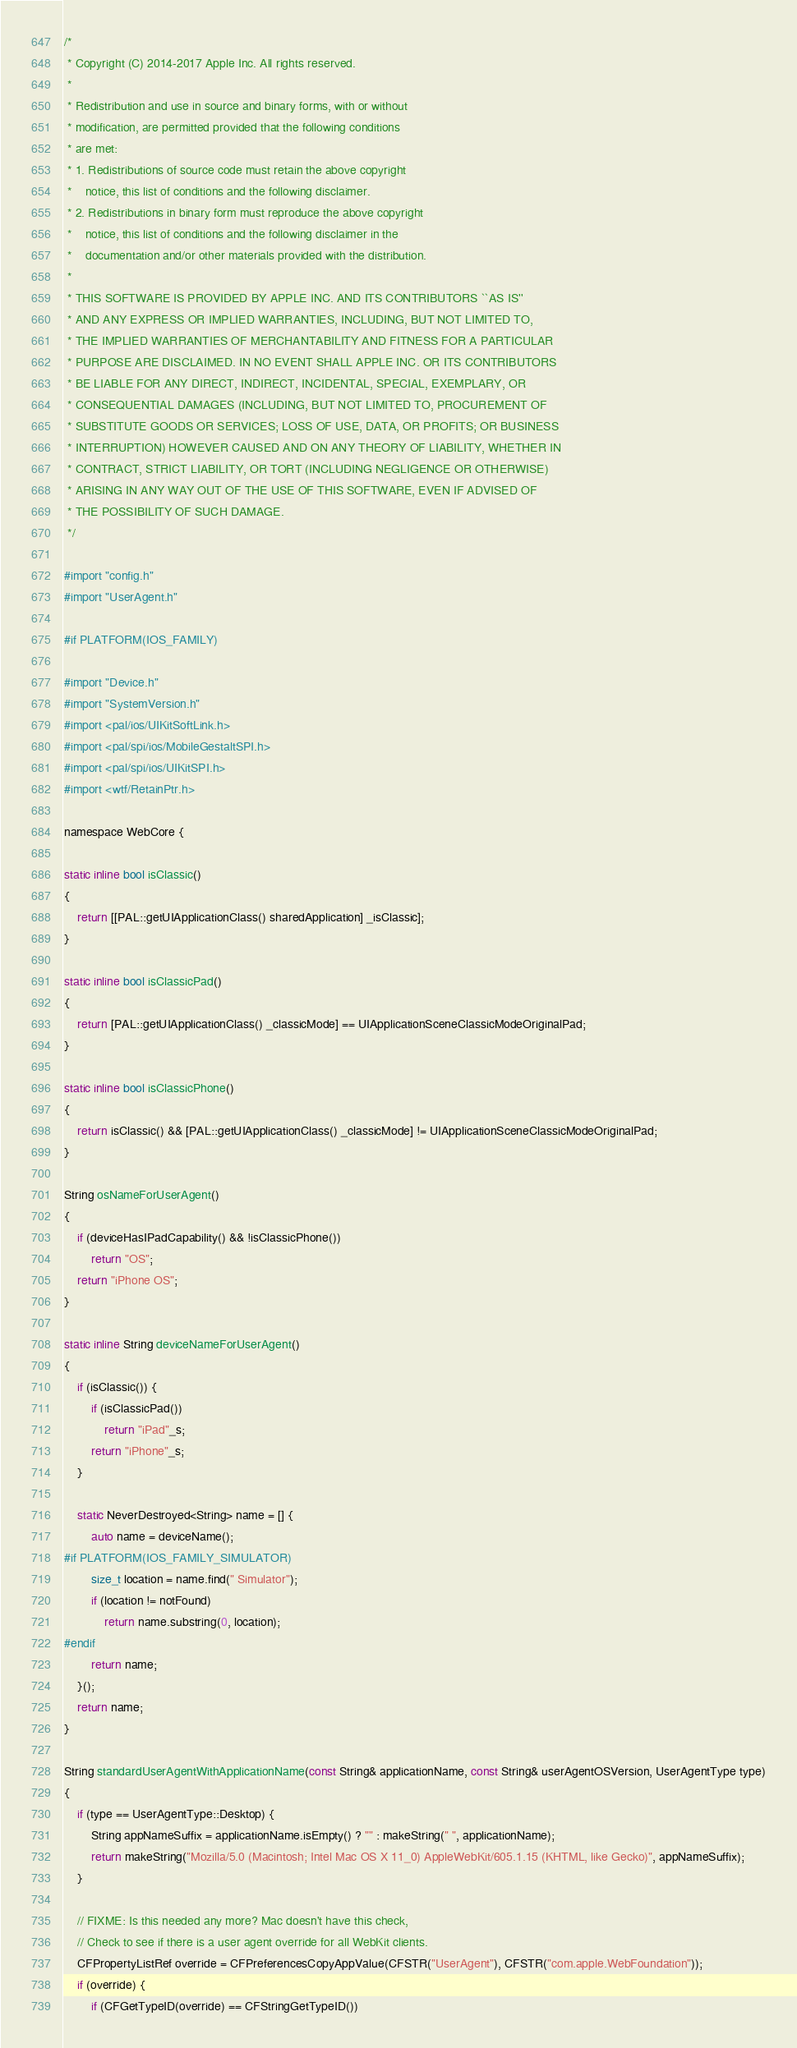<code> <loc_0><loc_0><loc_500><loc_500><_ObjectiveC_>/*
 * Copyright (C) 2014-2017 Apple Inc. All rights reserved.
 *
 * Redistribution and use in source and binary forms, with or without
 * modification, are permitted provided that the following conditions
 * are met:
 * 1. Redistributions of source code must retain the above copyright
 *    notice, this list of conditions and the following disclaimer.
 * 2. Redistributions in binary form must reproduce the above copyright
 *    notice, this list of conditions and the following disclaimer in the
 *    documentation and/or other materials provided with the distribution.
 *
 * THIS SOFTWARE IS PROVIDED BY APPLE INC. AND ITS CONTRIBUTORS ``AS IS''
 * AND ANY EXPRESS OR IMPLIED WARRANTIES, INCLUDING, BUT NOT LIMITED TO,
 * THE IMPLIED WARRANTIES OF MERCHANTABILITY AND FITNESS FOR A PARTICULAR
 * PURPOSE ARE DISCLAIMED. IN NO EVENT SHALL APPLE INC. OR ITS CONTRIBUTORS
 * BE LIABLE FOR ANY DIRECT, INDIRECT, INCIDENTAL, SPECIAL, EXEMPLARY, OR
 * CONSEQUENTIAL DAMAGES (INCLUDING, BUT NOT LIMITED TO, PROCUREMENT OF
 * SUBSTITUTE GOODS OR SERVICES; LOSS OF USE, DATA, OR PROFITS; OR BUSINESS
 * INTERRUPTION) HOWEVER CAUSED AND ON ANY THEORY OF LIABILITY, WHETHER IN
 * CONTRACT, STRICT LIABILITY, OR TORT (INCLUDING NEGLIGENCE OR OTHERWISE)
 * ARISING IN ANY WAY OUT OF THE USE OF THIS SOFTWARE, EVEN IF ADVISED OF
 * THE POSSIBILITY OF SUCH DAMAGE.
 */

#import "config.h"
#import "UserAgent.h"

#if PLATFORM(IOS_FAMILY)

#import "Device.h"
#import "SystemVersion.h"
#import <pal/ios/UIKitSoftLink.h>
#import <pal/spi/ios/MobileGestaltSPI.h>
#import <pal/spi/ios/UIKitSPI.h>
#import <wtf/RetainPtr.h>

namespace WebCore {

static inline bool isClassic()
{
    return [[PAL::getUIApplicationClass() sharedApplication] _isClassic];
}

static inline bool isClassicPad()
{
    return [PAL::getUIApplicationClass() _classicMode] == UIApplicationSceneClassicModeOriginalPad;
}

static inline bool isClassicPhone()
{
    return isClassic() && [PAL::getUIApplicationClass() _classicMode] != UIApplicationSceneClassicModeOriginalPad;
}

String osNameForUserAgent()
{
    if (deviceHasIPadCapability() && !isClassicPhone())
        return "OS";
    return "iPhone OS";
}

static inline String deviceNameForUserAgent()
{
    if (isClassic()) {
        if (isClassicPad())
            return "iPad"_s;
        return "iPhone"_s;
    }

    static NeverDestroyed<String> name = [] {
        auto name = deviceName();
#if PLATFORM(IOS_FAMILY_SIMULATOR)
        size_t location = name.find(" Simulator");
        if (location != notFound)
            return name.substring(0, location);
#endif
        return name;
    }();
    return name;
}

String standardUserAgentWithApplicationName(const String& applicationName, const String& userAgentOSVersion, UserAgentType type)
{
    if (type == UserAgentType::Desktop) {
        String appNameSuffix = applicationName.isEmpty() ? "" : makeString(" ", applicationName);
        return makeString("Mozilla/5.0 (Macintosh; Intel Mac OS X 11_0) AppleWebKit/605.1.15 (KHTML, like Gecko)", appNameSuffix);
    }

    // FIXME: Is this needed any more? Mac doesn't have this check,
    // Check to see if there is a user agent override for all WebKit clients.
    CFPropertyListRef override = CFPreferencesCopyAppValue(CFSTR("UserAgent"), CFSTR("com.apple.WebFoundation"));
    if (override) {
        if (CFGetTypeID(override) == CFStringGetTypeID())</code> 